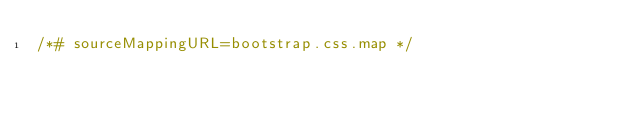<code> <loc_0><loc_0><loc_500><loc_500><_CSS_>/*# sourceMappingURL=bootstrap.css.map */
</code> 